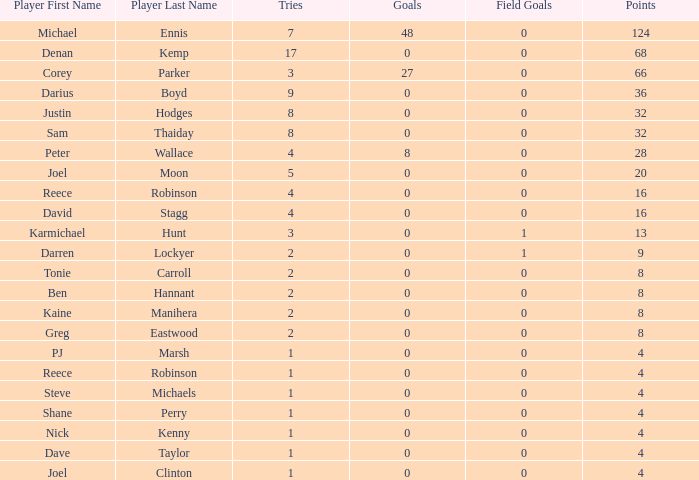What is the total number of field goals of Denan Kemp, who has more than 4 tries, more than 32 points, and 0 goals? 1.0. 